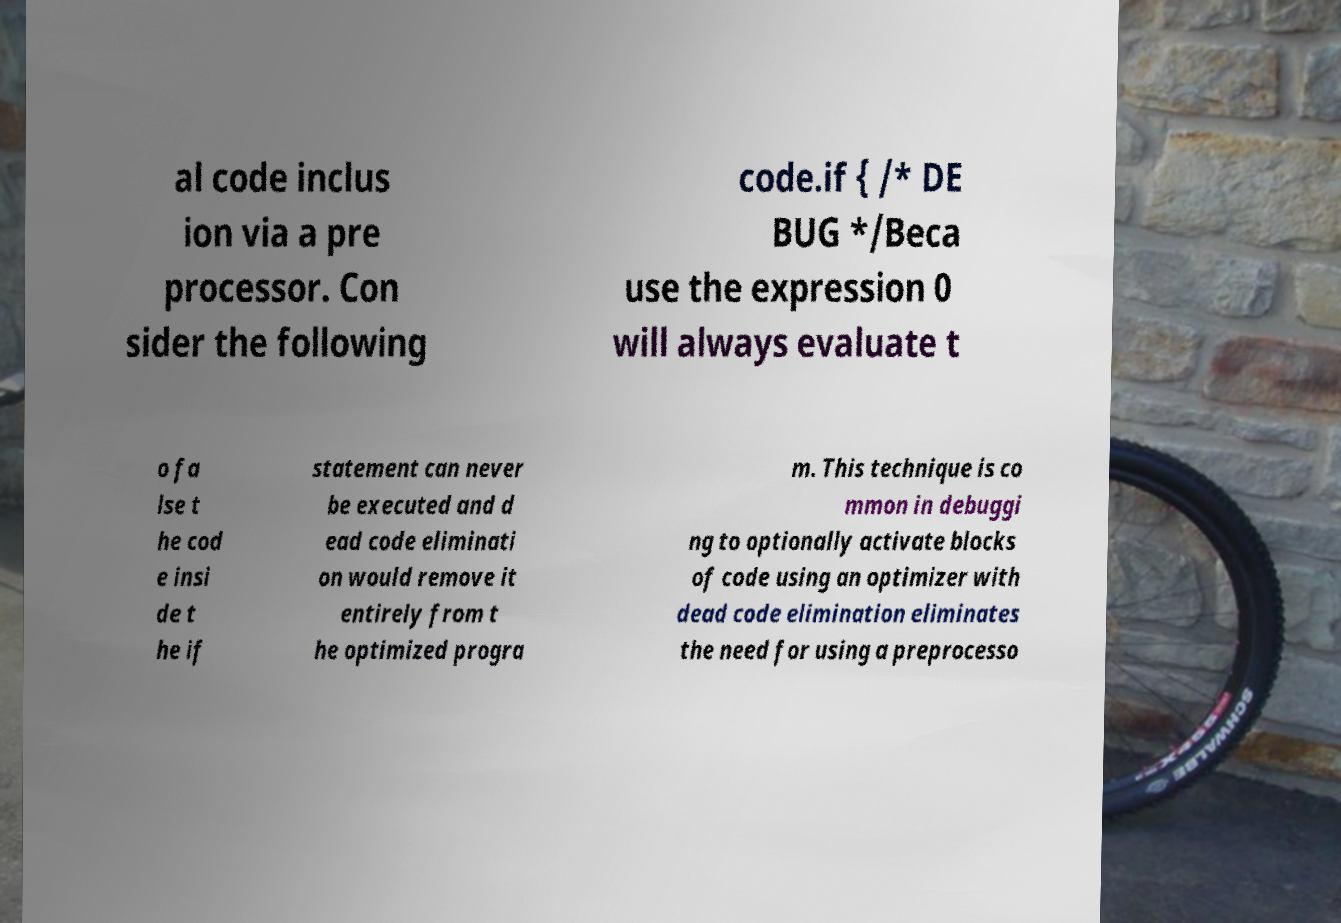Can you accurately transcribe the text from the provided image for me? al code inclus ion via a pre processor. Con sider the following code.if { /* DE BUG */Beca use the expression 0 will always evaluate t o fa lse t he cod e insi de t he if statement can never be executed and d ead code eliminati on would remove it entirely from t he optimized progra m. This technique is co mmon in debuggi ng to optionally activate blocks of code using an optimizer with dead code elimination eliminates the need for using a preprocesso 